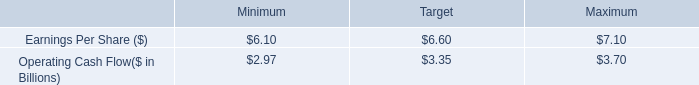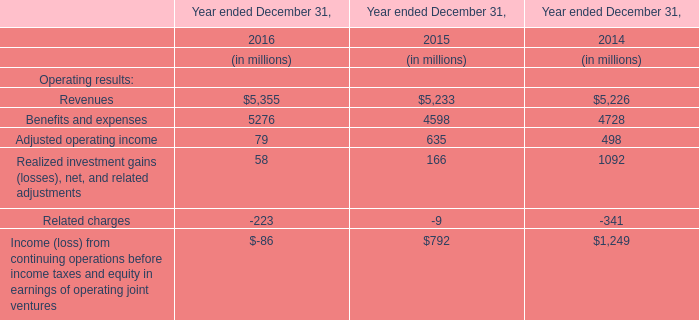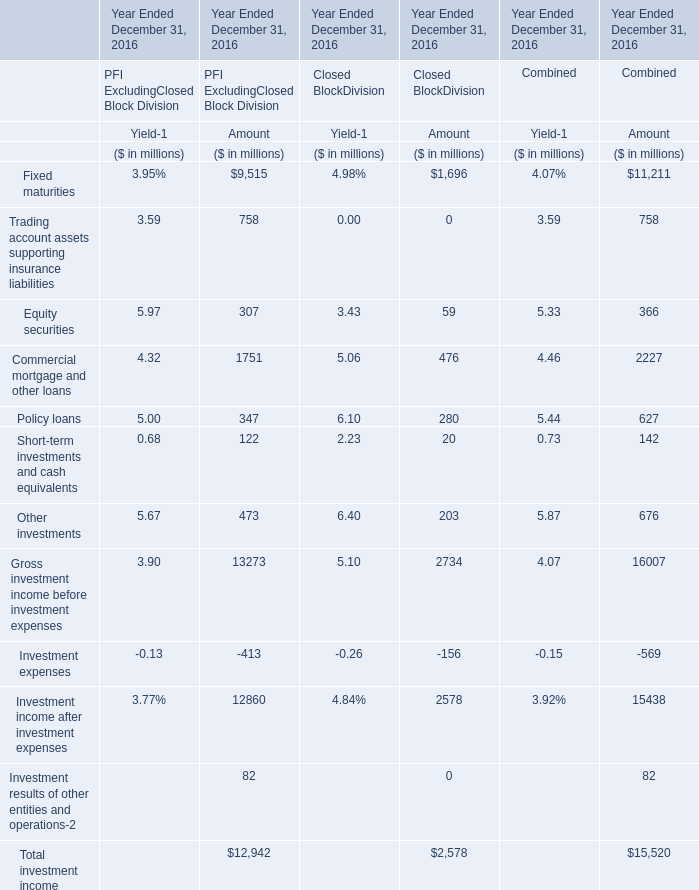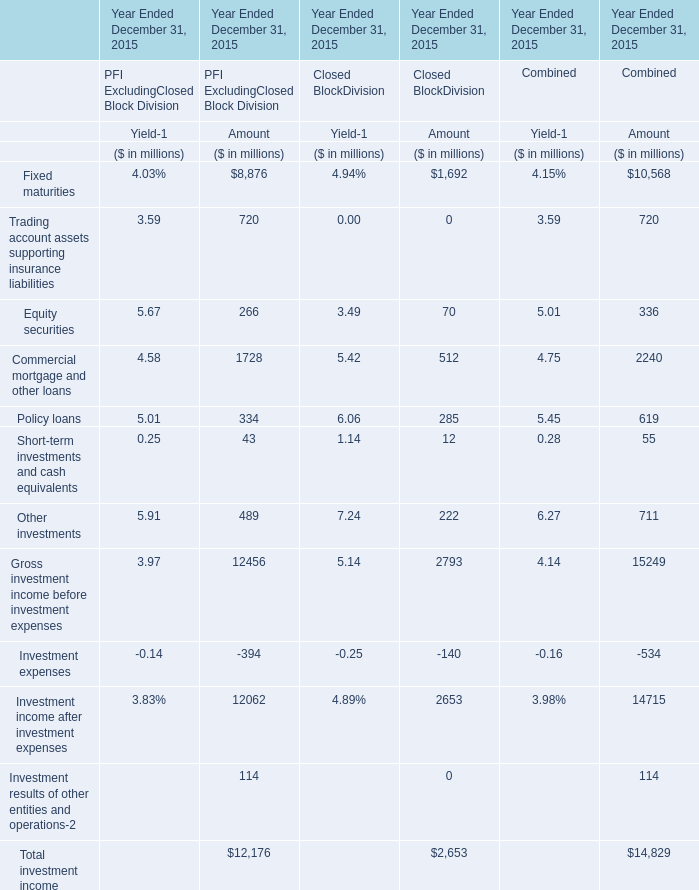What is the percentage of Fixed maturities in relation to the total for PFI ExcludingClosed Block Division of Amout? 
Computations: (9515 / 12942)
Answer: 0.7352. 